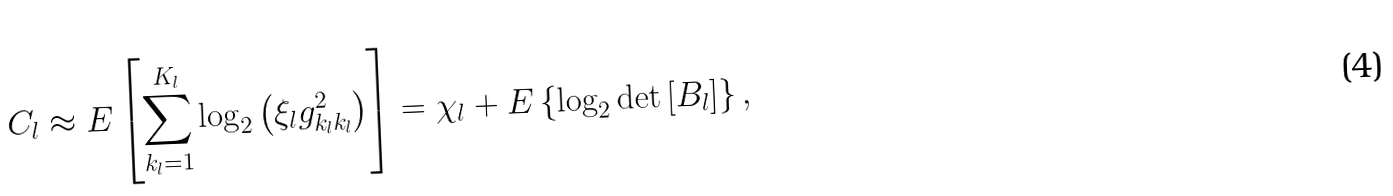Convert formula to latex. <formula><loc_0><loc_0><loc_500><loc_500>C _ { l } \approx E \left [ \sum _ { k _ { l } = 1 } ^ { K _ { l } } \log _ { 2 } \left ( \xi _ { l } g ^ { 2 } _ { k _ { l } k _ { l } } \right ) \right ] = \chi _ { l } + E \left \{ \log _ { 2 } \det \left [ B _ { l } \right ] \right \} ,</formula> 